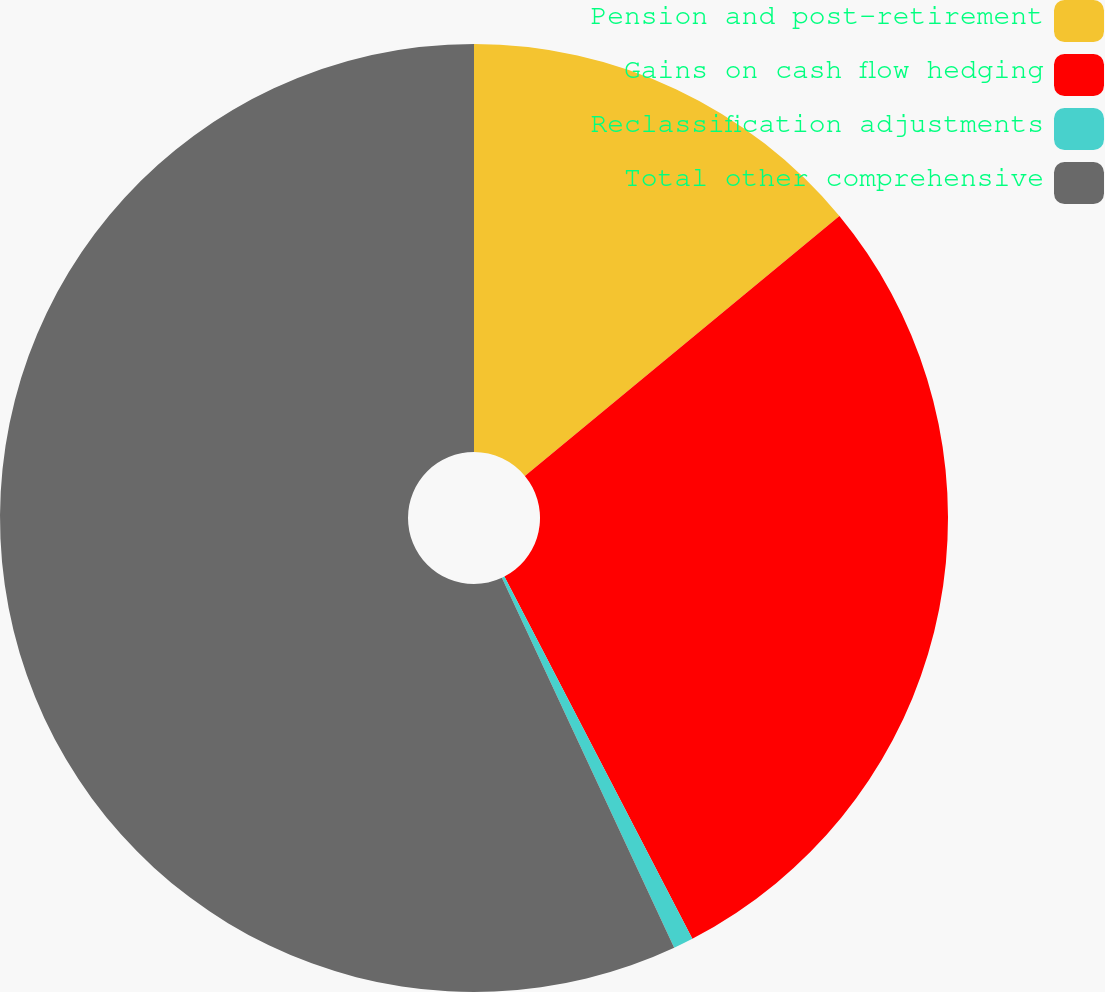Convert chart to OTSL. <chart><loc_0><loc_0><loc_500><loc_500><pie_chart><fcel>Pension and post-retirement<fcel>Gains on cash flow hedging<fcel>Reclassification adjustments<fcel>Total other comprehensive<nl><fcel>14.01%<fcel>28.37%<fcel>0.68%<fcel>56.94%<nl></chart> 